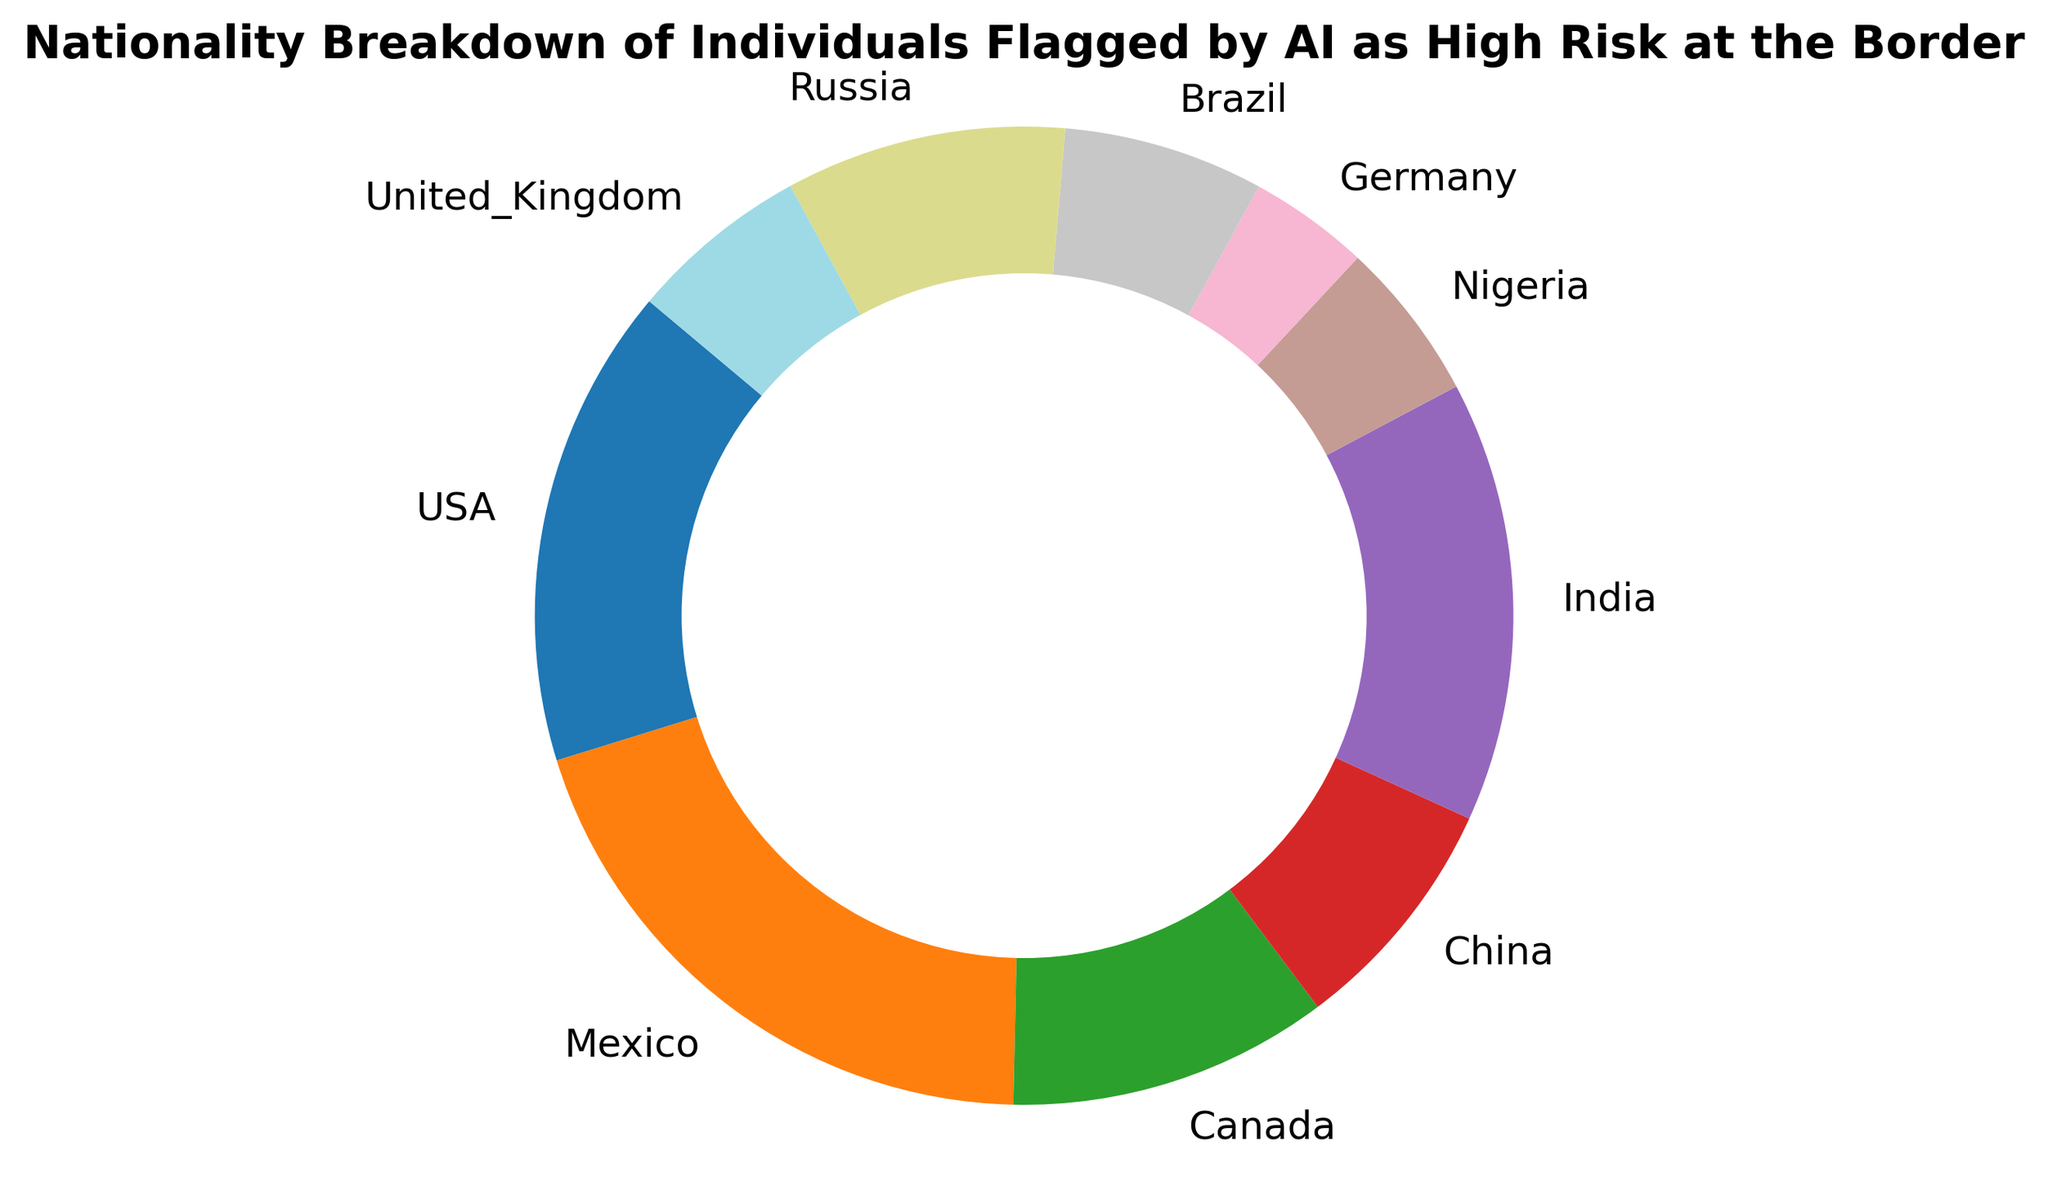What is the nationality with the highest count of individuals flagged as high risk? The figure provides the counts for each nationality. By examining the size of each slice, Mexico has the largest slice.
Answer: Mexico What is the combined percentage of individuals from the USA and Canada flagged as high risk? The percentages for the USA and Canada are each shown in the figure. Adding their percentages together, the USA is 19.4% and Canada is 12.9%. So, 19.4% + 12.9% = 32.3%.
Answer: 32.3% Which nationality has a smaller percentage flagged as high risk than both Brazil and Nigeria? By comparing the pie slices, Germany's slice appears smaller than both Brazil's and Nigeria's.
Answer: Germany How much larger is the percentage of individuals flagged from India than from China? The figure shows the percentages for each slice. For India, it's 17.7%, and for China, it's 9.7%. The difference is 17.7% - 9.7% = 8%.
Answer: 8% What is the total number of individuals flagged from countries in Europe? The European countries listed are Germany, the United Kingdom, and Russia. Adding their counts: Germany (30) + United Kingdom (45) + Russia (70) = 145.
Answer: 145 What is the average number of individuals flagged for the top three nationalities with the highest counts? By identifying the top three slices (Mexico, USA, and India) and averaging their counts: (150 + 120 + 110) / 3 = 126.67.
Answer: 126.67 How does the count of individuals flagged from China compare to those flagged from Brazil and Nigeria combined? By verifying the figure, China's count is 60. For Brazil and Nigeria combined, it is 50 + 40 = 90. China (60) is less than Brazil and Nigeria combined (90).
Answer: Less Which nationality's flagged individuals make up a slice that is visually similar in size to Canada's slice? Examining the pie chart, the United Kingdom's slice appears visually similar to Canada's slice.
Answer: United Kingdom 